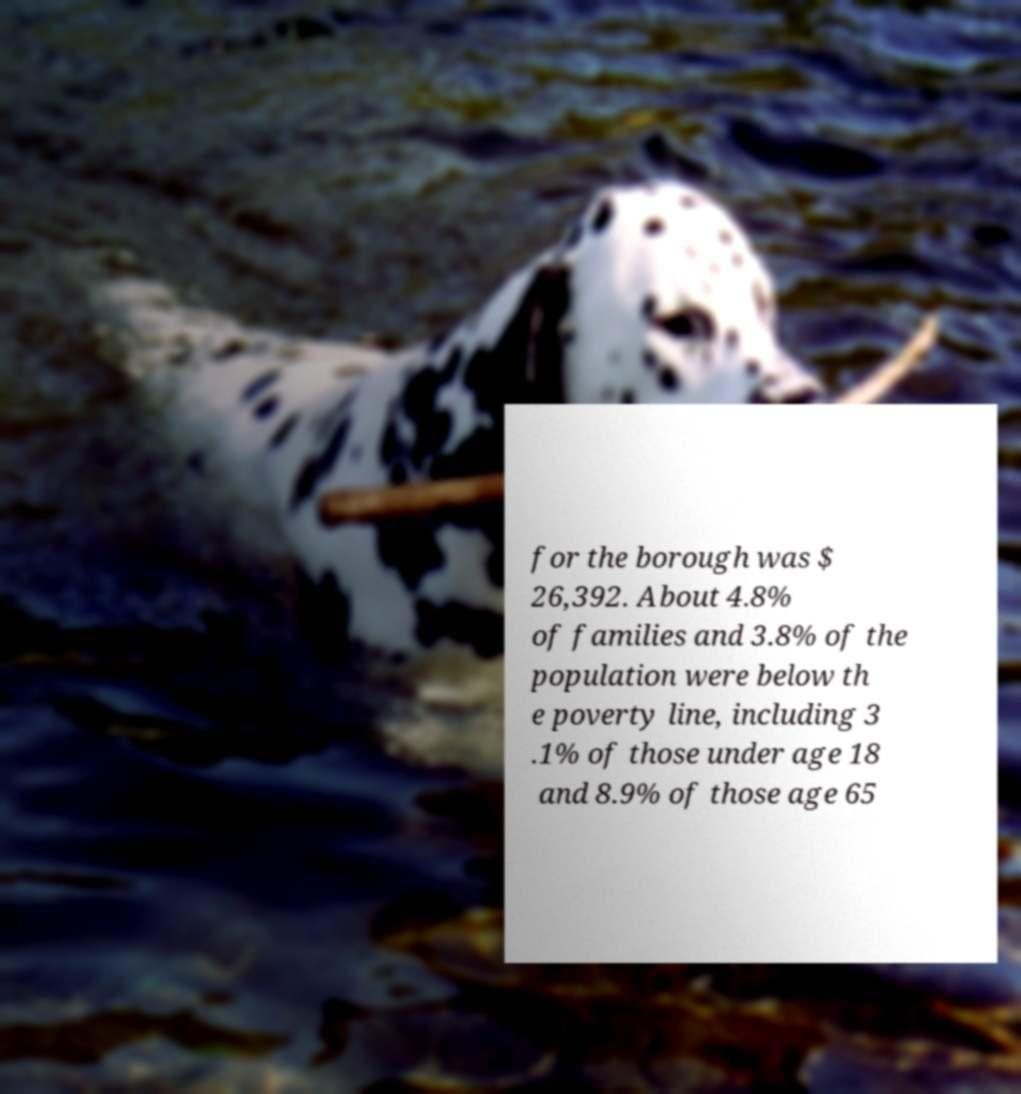What messages or text are displayed in this image? I need them in a readable, typed format. for the borough was $ 26,392. About 4.8% of families and 3.8% of the population were below th e poverty line, including 3 .1% of those under age 18 and 8.9% of those age 65 